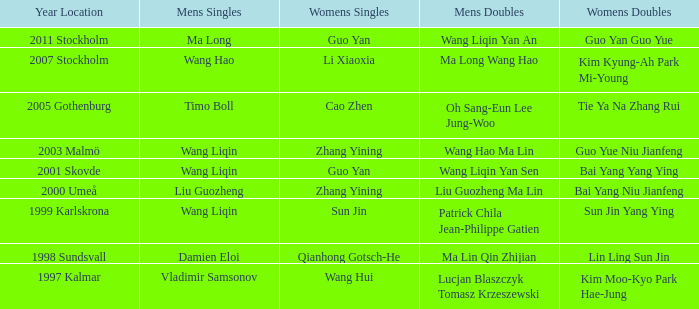When and where did bai yang and niu jianfeng become the champions in women's doubles? 2000 Umeå. 